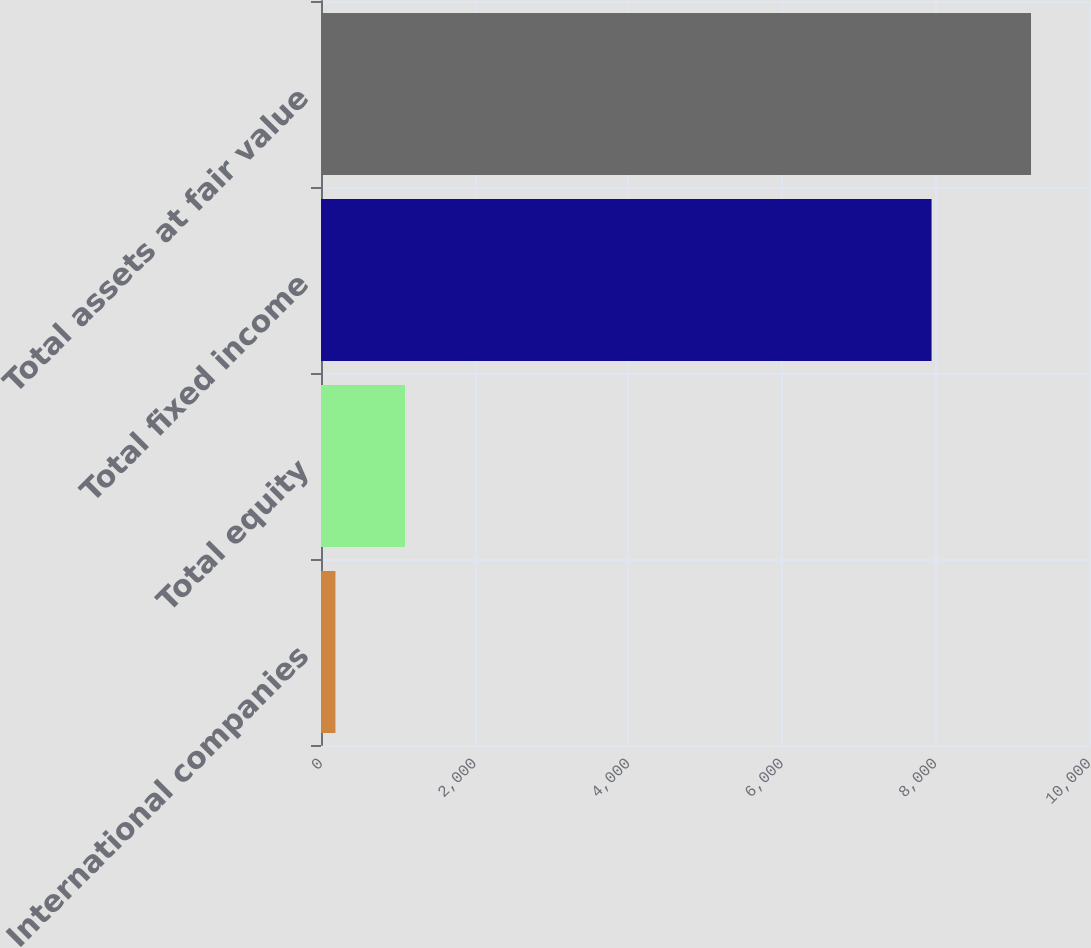Convert chart. <chart><loc_0><loc_0><loc_500><loc_500><bar_chart><fcel>International companies<fcel>Total equity<fcel>Total fixed income<fcel>Total assets at fair value<nl><fcel>188<fcel>1093.7<fcel>7950<fcel>9245<nl></chart> 